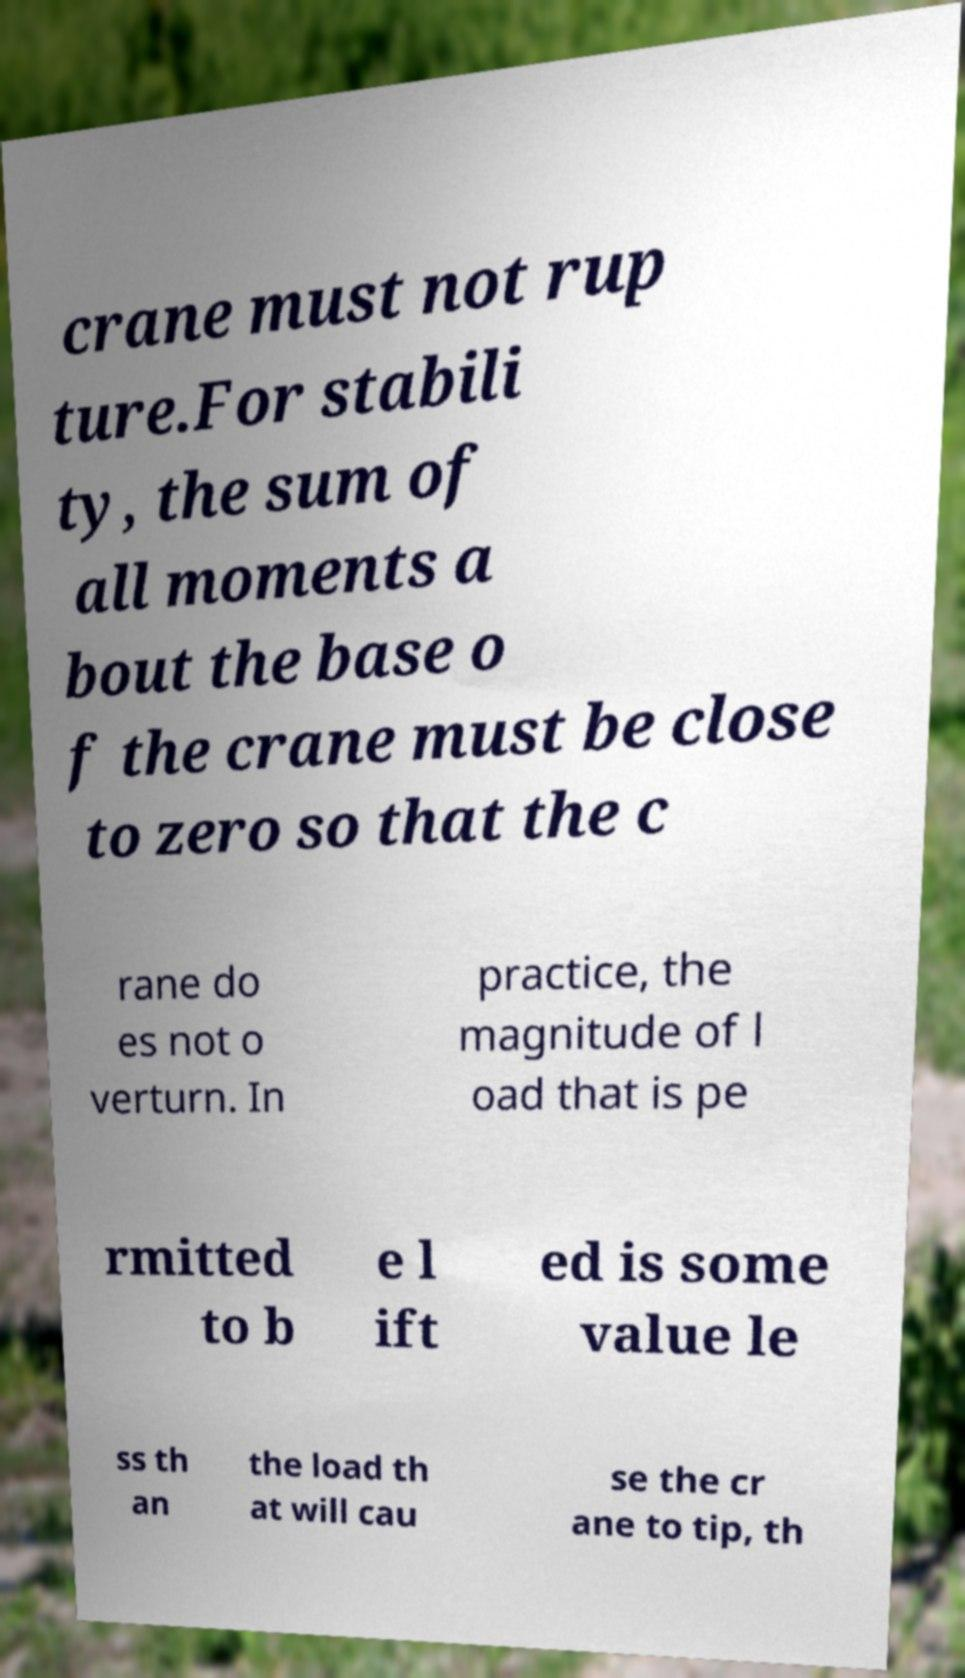Could you assist in decoding the text presented in this image and type it out clearly? crane must not rup ture.For stabili ty, the sum of all moments a bout the base o f the crane must be close to zero so that the c rane do es not o verturn. In practice, the magnitude of l oad that is pe rmitted to b e l ift ed is some value le ss th an the load th at will cau se the cr ane to tip, th 